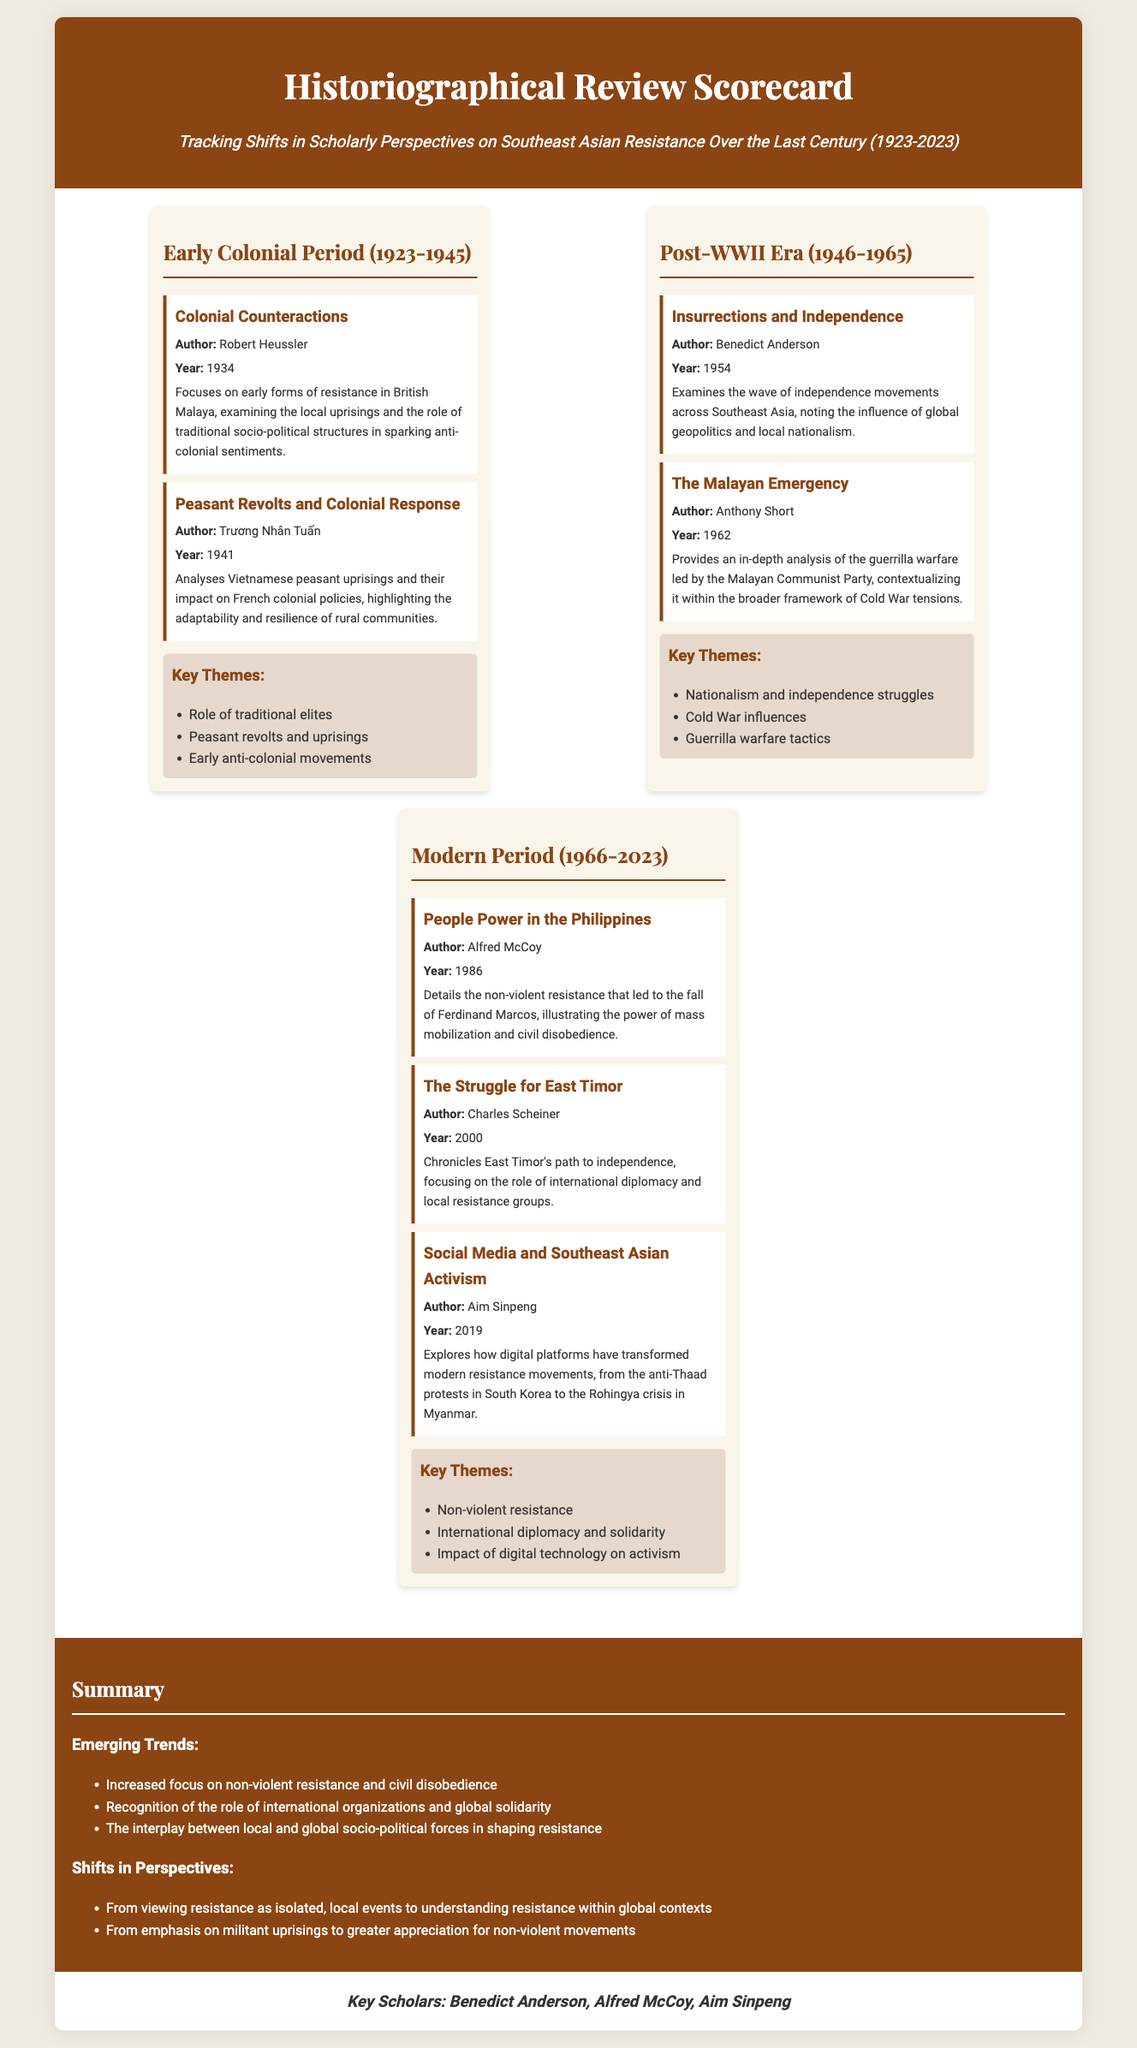what is the title of the scorecard? The title is explicitly stated in the document as "Historiographical Review Scorecard".
Answer: Historiographical Review Scorecard who authored the paper "People Power in the Philippines"? The author is listed in the document as Alfred McCoy.
Answer: Alfred McCoy what year was "Insurrections and Independence" published? The document specifies the publication year as 1954.
Answer: 1954 what is a key theme from the early colonial period section? Key themes are listed and one is "Role of traditional elites".
Answer: Role of traditional elites how many papers are listed in the Modern Period category? The document details three papers under this category.
Answer: 3 what shift in perspectives is noted in the summary? The shift observed is "From viewing resistance as isolated, local events to understanding resistance within global contexts".
Answer: From viewing resistance as isolated, local events to understanding resistance within global contexts who is recognized as a key scholar in the scorecard? The document mentions Benedict Anderson among key scholars.
Answer: Benedict Anderson which event is associated with Anthony Short's analysis? The document indicates that his analysis is about the "Malayan Emergency".
Answer: Malayan Emergency 